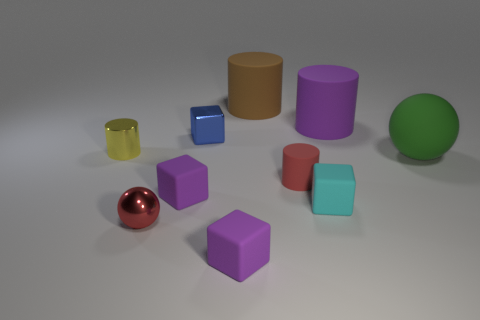Are any large green things visible?
Your answer should be compact. Yes. Does the big sphere have the same color as the small shiny block?
Provide a short and direct response. No. How many large objects are either brown rubber things or gray metal cubes?
Your response must be concise. 1. Is there any other thing that has the same color as the large sphere?
Offer a terse response. No. There is a red object that is the same material as the tiny yellow thing; what is its shape?
Provide a succinct answer. Sphere. What is the size of the red metal object that is in front of the tiny yellow thing?
Offer a terse response. Small. What shape is the tiny cyan rubber object?
Keep it short and to the point. Cube. Do the sphere to the left of the brown object and the brown rubber object behind the red metallic object have the same size?
Your response must be concise. No. How big is the cube right of the big brown rubber cylinder that is on the right side of the tiny cylinder on the left side of the small blue metal thing?
Give a very brief answer. Small. There is a purple object to the right of the rubber cylinder that is in front of the object right of the large purple thing; what shape is it?
Offer a very short reply. Cylinder. 